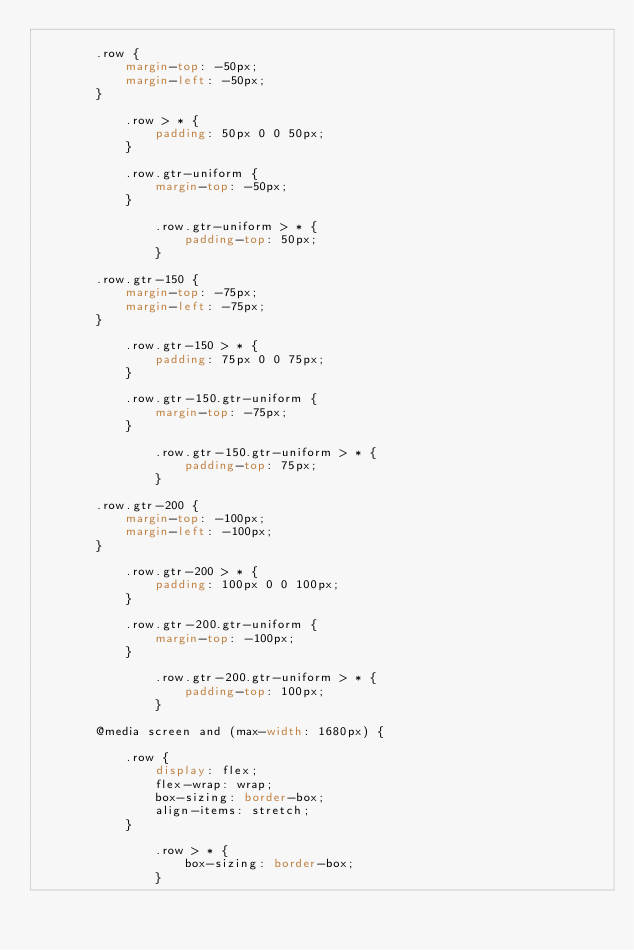Convert code to text. <code><loc_0><loc_0><loc_500><loc_500><_CSS_>
		.row {
			margin-top: -50px;
			margin-left: -50px;
		}

			.row > * {
				padding: 50px 0 0 50px;
			}

			.row.gtr-uniform {
				margin-top: -50px;
			}

				.row.gtr-uniform > * {
					padding-top: 50px;
				}

		.row.gtr-150 {
			margin-top: -75px;
			margin-left: -75px;
		}

			.row.gtr-150 > * {
				padding: 75px 0 0 75px;
			}

			.row.gtr-150.gtr-uniform {
				margin-top: -75px;
			}

				.row.gtr-150.gtr-uniform > * {
					padding-top: 75px;
				}

		.row.gtr-200 {
			margin-top: -100px;
			margin-left: -100px;
		}

			.row.gtr-200 > * {
				padding: 100px 0 0 100px;
			}

			.row.gtr-200.gtr-uniform {
				margin-top: -100px;
			}

				.row.gtr-200.gtr-uniform > * {
					padding-top: 100px;
				}

		@media screen and (max-width: 1680px) {

			.row {
				display: flex;
				flex-wrap: wrap;
				box-sizing: border-box;
				align-items: stretch;
			}

				.row > * {
					box-sizing: border-box;
				}
</code> 